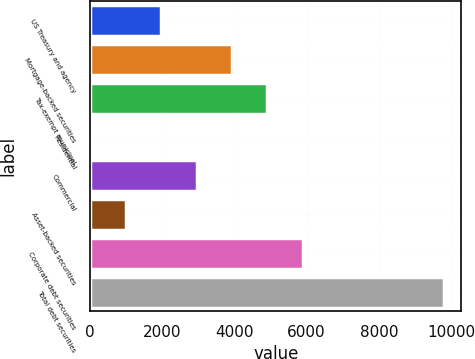Convert chart. <chart><loc_0><loc_0><loc_500><loc_500><bar_chart><fcel>US Treasury and agency<fcel>Mortgage-backed securities<fcel>Tax-exempt municipal<fcel>Residential<fcel>Commercial<fcel>Asset-backed securities<fcel>Corporate debt securities<fcel>Total debt securities<nl><fcel>1977.6<fcel>3933.2<fcel>4911<fcel>22<fcel>2955.4<fcel>999.8<fcel>5888.8<fcel>9800<nl></chart> 